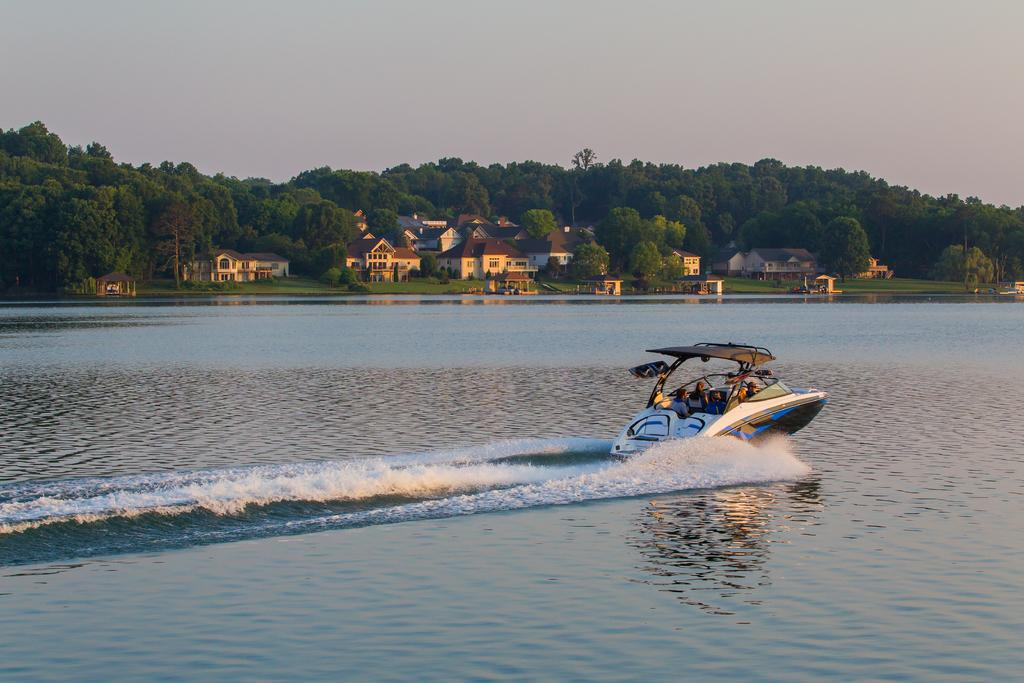What is the main subject of the image? There are people on a boat in the image. What can be seen in the water surrounding the boat? Waves are visible in the water. What is visible in the background of the image? There are trees and houses in the background of the image. What type of plant is growing inside the cup on the boat? There is no cup or plant present on the boat in the image. 